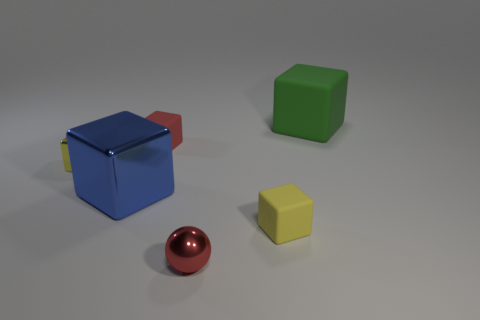Subtract all yellow matte cubes. How many cubes are left? 4 Add 1 large blocks. How many objects exist? 7 Subtract 0 gray blocks. How many objects are left? 6 Subtract all blocks. How many objects are left? 1 Subtract 3 cubes. How many cubes are left? 2 Subtract all gray cubes. Subtract all brown spheres. How many cubes are left? 5 Subtract all gray cylinders. How many green cubes are left? 1 Subtract all small gray cylinders. Subtract all small red matte blocks. How many objects are left? 5 Add 6 spheres. How many spheres are left? 7 Add 2 tiny purple rubber cubes. How many tiny purple rubber cubes exist? 2 